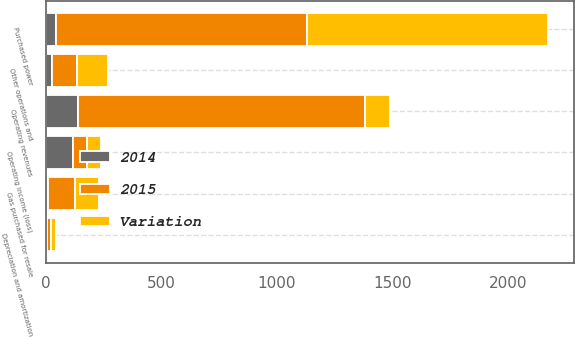Convert chart. <chart><loc_0><loc_0><loc_500><loc_500><stacked_bar_chart><ecel><fcel>Operating revenues<fcel>Purchased power<fcel>Gas purchased for resale<fcel>Other operations and<fcel>Depreciation and amortization<fcel>Operating income (loss)<nl><fcel>Variation<fcel>106<fcel>1044<fcel>106<fcel>134<fcel>22<fcel>58<nl><fcel>2015<fcel>1244<fcel>1088<fcel>115<fcel>108<fcel>19<fcel>60<nl><fcel>2014<fcel>139<fcel>44<fcel>9<fcel>26<fcel>3<fcel>118<nl></chart> 